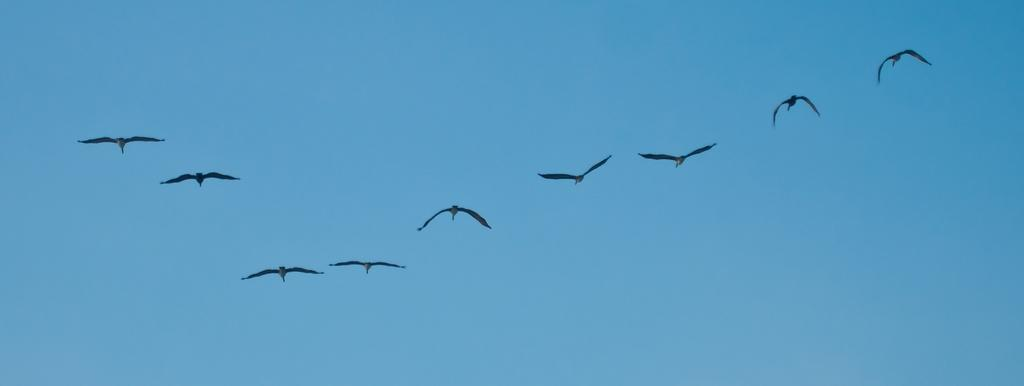What can be seen in the background of the image? There is a sky visible in the image. What is happening in the sky in the image? There are birds flying in the sky in the image. Where is the crate located in the image? There is no crate present in the image. What type of grass can be seen growing in the image? There is no grass present in the image. 